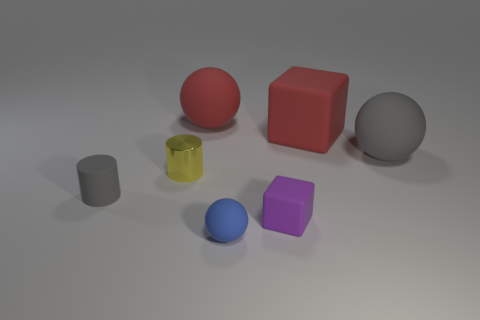What might be the purpose of creating this image? The purpose of this image could be multifaceted: it might serve as a test for rendering techniques, showcasing how light interacts with objects of different colors and shapes. It could also be used for educational purposes to teach about geometry, color theory, or 3D modeling. In a commercial setting, it may be part of a catalog or an example image used to exhibit digital design capabilities. Can this image tell us something about the lighting condition? Absolutely, the image suggests a single diffuse light source above and slightly to the front of the objects, as implied by the soft shadows that appear behind and to the right of each object. The even lighting and lack of multiple shadows or highlights suggest the absence of additional light sources. 